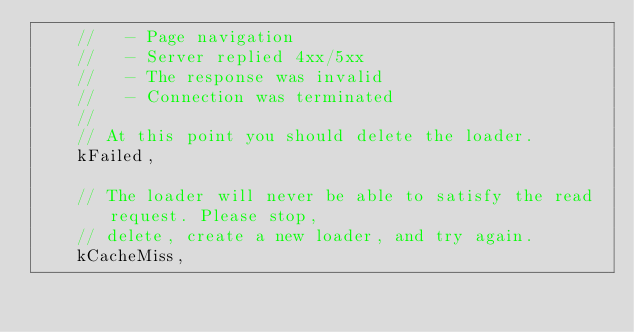<code> <loc_0><loc_0><loc_500><loc_500><_C_>    //   - Page navigation
    //   - Server replied 4xx/5xx
    //   - The response was invalid
    //   - Connection was terminated
    //
    // At this point you should delete the loader.
    kFailed,

    // The loader will never be able to satisfy the read request. Please stop,
    // delete, create a new loader, and try again.
    kCacheMiss,</code> 